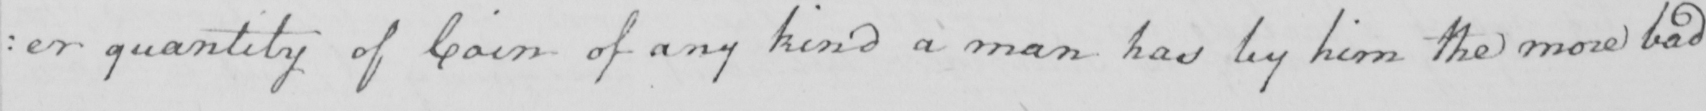Can you read and transcribe this handwriting? : er quantity of Coin of any kind a man has by him the more bad 